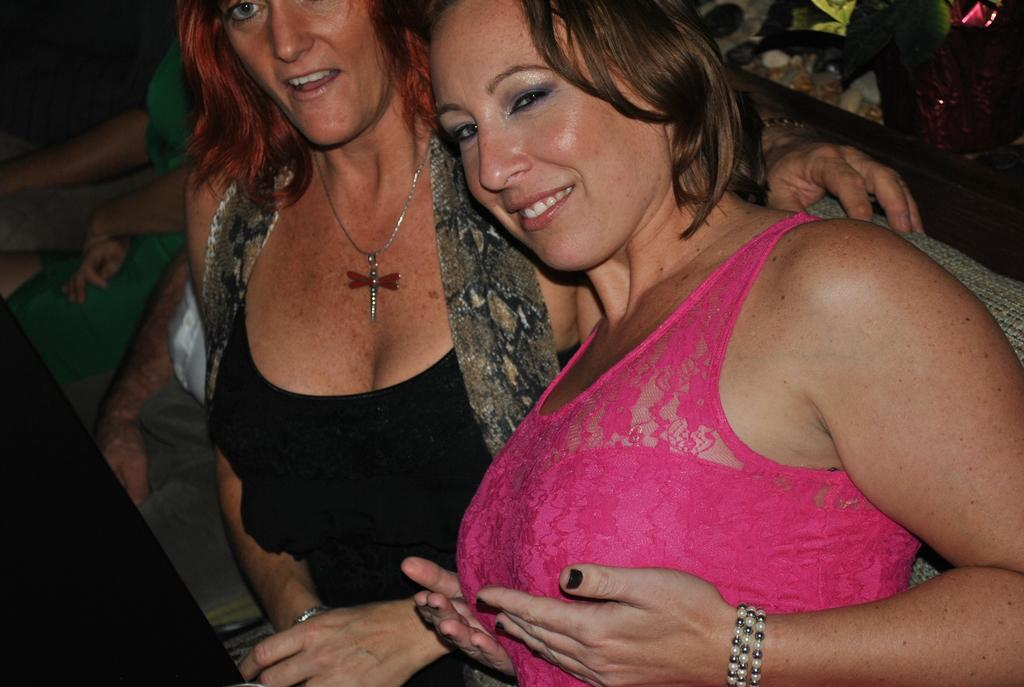How many people are in the image? There are two women in the image. What are the women doing in the image? The women are standing in the image. What is the facial expression of the women? The women are smiling in the image. What type of riddle can be seen in the middle of the image? There is no riddle present in the image; it features two women standing and smiling. 